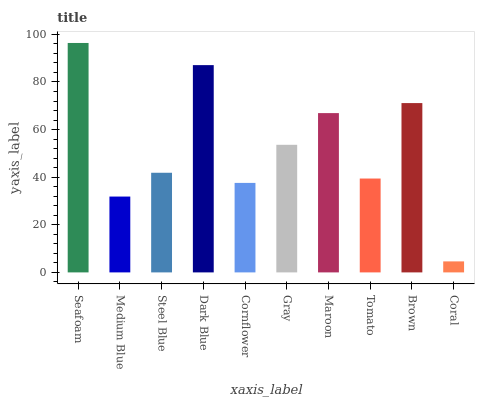Is Medium Blue the minimum?
Answer yes or no. No. Is Medium Blue the maximum?
Answer yes or no. No. Is Seafoam greater than Medium Blue?
Answer yes or no. Yes. Is Medium Blue less than Seafoam?
Answer yes or no. Yes. Is Medium Blue greater than Seafoam?
Answer yes or no. No. Is Seafoam less than Medium Blue?
Answer yes or no. No. Is Gray the high median?
Answer yes or no. Yes. Is Steel Blue the low median?
Answer yes or no. Yes. Is Maroon the high median?
Answer yes or no. No. Is Dark Blue the low median?
Answer yes or no. No. 